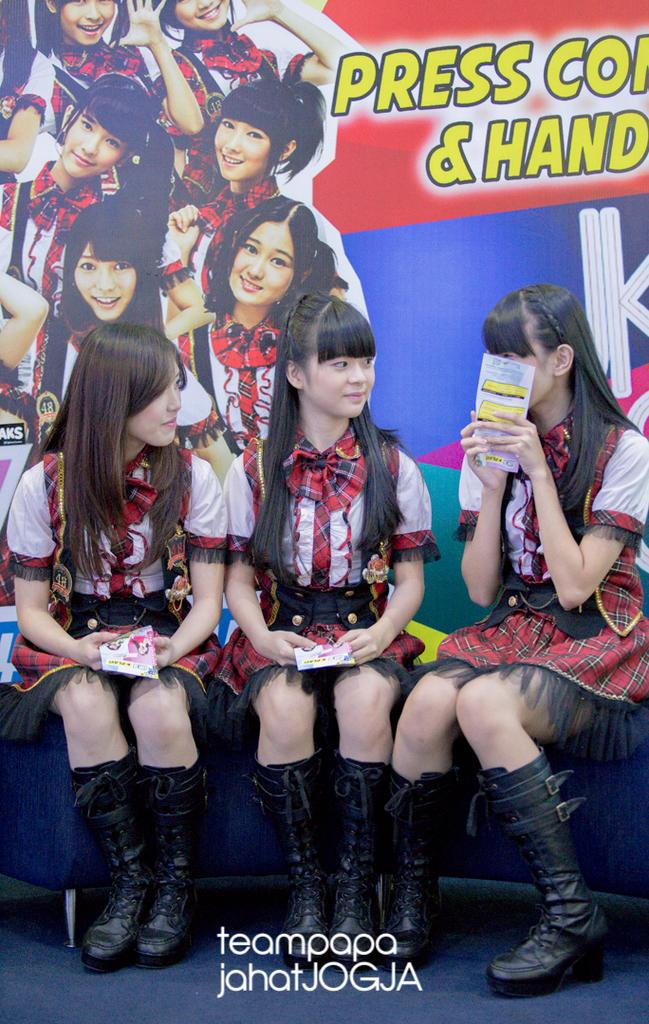How many people are in the image? There are three persons in the image. What are the persons doing in the image? The persons are sitting on a sofa and holding books. What can be seen in the background of the image? There is a banner in the background of the image. How many ladybugs can be seen on the sofa in the image? There are no ladybugs present in the image; the persons are holding books and sitting on the sofa. What type of nose is visible on the person sitting on the left side of the sofa? There is no specific nose visible on any of the persons in the image, as the focus is on their actions and the books they are holding. 